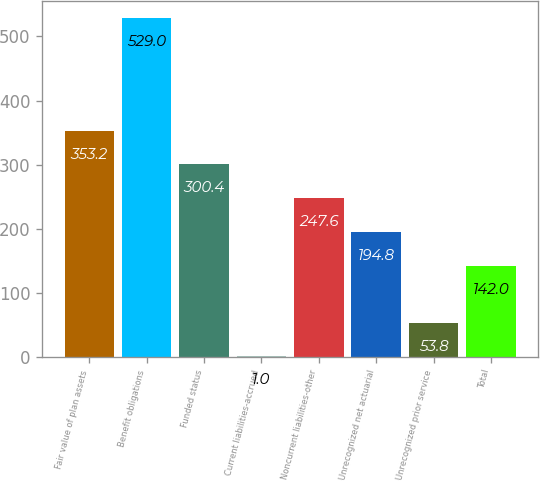Convert chart to OTSL. <chart><loc_0><loc_0><loc_500><loc_500><bar_chart><fcel>Fair value of plan assets<fcel>Benefit obligations<fcel>Funded status<fcel>Current liabilities-accrued<fcel>Noncurrent liabilities-other<fcel>Unrecognized net actuarial<fcel>Unrecognized prior service<fcel>Total<nl><fcel>353.2<fcel>529<fcel>300.4<fcel>1<fcel>247.6<fcel>194.8<fcel>53.8<fcel>142<nl></chart> 